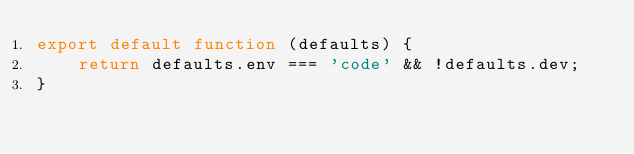<code> <loc_0><loc_0><loc_500><loc_500><_JavaScript_>export default function (defaults) {
    return defaults.env === 'code' && !defaults.dev;
}
</code> 